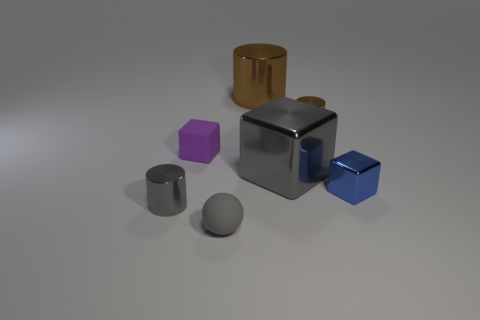There is another cylinder that is the same color as the large shiny cylinder; what material is it?
Offer a terse response. Metal. Is there any other thing that is the same shape as the big gray metal object?
Provide a short and direct response. Yes. How many things are things that are behind the gray matte thing or big red matte cubes?
Your response must be concise. 6. Does the large object in front of the large brown shiny cylinder have the same color as the tiny sphere?
Keep it short and to the point. Yes. There is a gray shiny object to the right of the small shiny thing that is left of the large brown metal cylinder; what shape is it?
Make the answer very short. Cube. Is the number of large brown shiny cylinders that are left of the small purple object less than the number of small gray cylinders that are right of the tiny gray cylinder?
Provide a succinct answer. No. The blue metallic object that is the same shape as the big gray object is what size?
Your answer should be compact. Small. Is there any other thing that has the same size as the gray shiny cylinder?
Ensure brevity in your answer.  Yes. What number of objects are either small things that are in front of the tiny blue block or tiny cubes behind the gray cube?
Give a very brief answer. 3. Is the purple object the same size as the matte sphere?
Make the answer very short. Yes. 